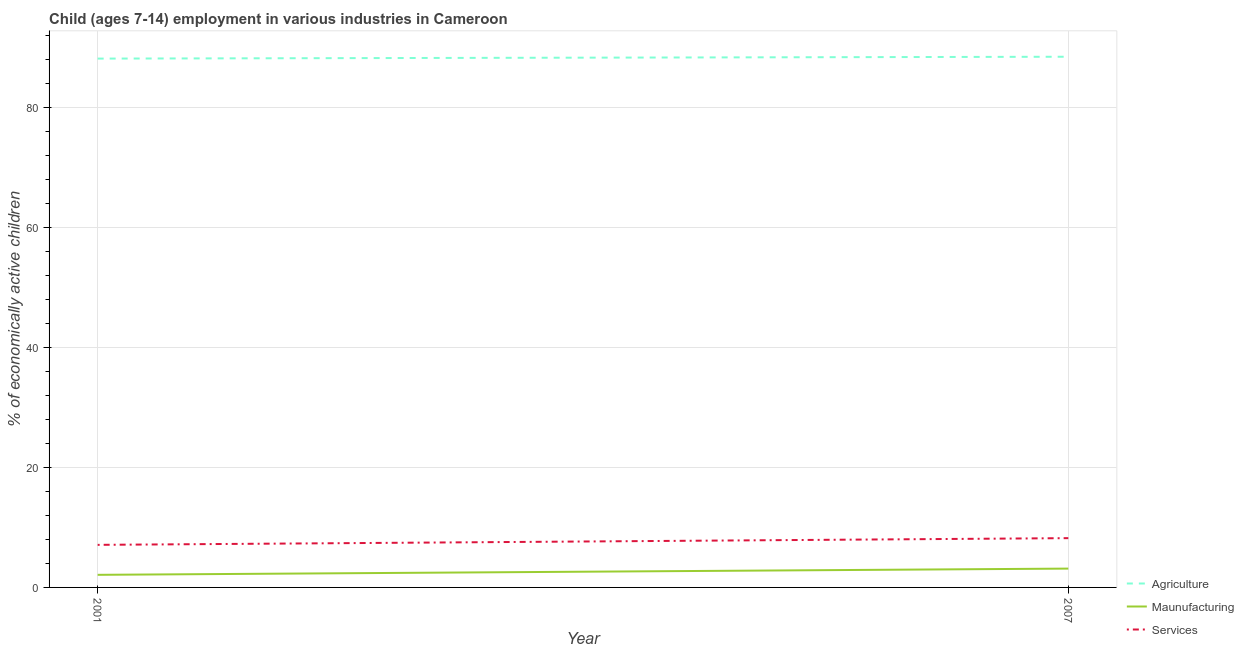Does the line corresponding to percentage of economically active children in services intersect with the line corresponding to percentage of economically active children in manufacturing?
Offer a very short reply. No. What is the percentage of economically active children in agriculture in 2007?
Give a very brief answer. 88.52. Across all years, what is the maximum percentage of economically active children in agriculture?
Keep it short and to the point. 88.52. Across all years, what is the minimum percentage of economically active children in agriculture?
Ensure brevity in your answer.  88.21. In which year was the percentage of economically active children in agriculture maximum?
Ensure brevity in your answer.  2007. What is the total percentage of economically active children in manufacturing in the graph?
Provide a succinct answer. 5.24. What is the difference between the percentage of economically active children in agriculture in 2001 and that in 2007?
Provide a short and direct response. -0.31. What is the difference between the percentage of economically active children in manufacturing in 2007 and the percentage of economically active children in services in 2001?
Provide a succinct answer. -3.96. What is the average percentage of economically active children in services per year?
Keep it short and to the point. 7.66. In the year 2001, what is the difference between the percentage of economically active children in services and percentage of economically active children in agriculture?
Give a very brief answer. -81.11. What is the ratio of the percentage of economically active children in agriculture in 2001 to that in 2007?
Provide a succinct answer. 1. Is the percentage of economically active children in services in 2001 less than that in 2007?
Make the answer very short. Yes. Is it the case that in every year, the sum of the percentage of economically active children in agriculture and percentage of economically active children in manufacturing is greater than the percentage of economically active children in services?
Offer a very short reply. Yes. Does the percentage of economically active children in services monotonically increase over the years?
Provide a short and direct response. Yes. Is the percentage of economically active children in services strictly less than the percentage of economically active children in manufacturing over the years?
Make the answer very short. No. What is the difference between two consecutive major ticks on the Y-axis?
Your answer should be very brief. 20. Does the graph contain grids?
Make the answer very short. Yes. What is the title of the graph?
Provide a succinct answer. Child (ages 7-14) employment in various industries in Cameroon. Does "Argument" appear as one of the legend labels in the graph?
Your answer should be compact. No. What is the label or title of the Y-axis?
Offer a terse response. % of economically active children. What is the % of economically active children in Agriculture in 2001?
Provide a succinct answer. 88.21. What is the % of economically active children of Maunufacturing in 2001?
Give a very brief answer. 2.1. What is the % of economically active children in Services in 2001?
Your response must be concise. 7.1. What is the % of economically active children of Agriculture in 2007?
Give a very brief answer. 88.52. What is the % of economically active children in Maunufacturing in 2007?
Offer a very short reply. 3.14. What is the % of economically active children of Services in 2007?
Keep it short and to the point. 8.22. Across all years, what is the maximum % of economically active children in Agriculture?
Give a very brief answer. 88.52. Across all years, what is the maximum % of economically active children of Maunufacturing?
Your answer should be compact. 3.14. Across all years, what is the maximum % of economically active children in Services?
Your response must be concise. 8.22. Across all years, what is the minimum % of economically active children of Agriculture?
Make the answer very short. 88.21. What is the total % of economically active children of Agriculture in the graph?
Offer a terse response. 176.73. What is the total % of economically active children of Maunufacturing in the graph?
Provide a short and direct response. 5.24. What is the total % of economically active children in Services in the graph?
Your response must be concise. 15.32. What is the difference between the % of economically active children in Agriculture in 2001 and that in 2007?
Provide a short and direct response. -0.31. What is the difference between the % of economically active children of Maunufacturing in 2001 and that in 2007?
Offer a very short reply. -1.04. What is the difference between the % of economically active children in Services in 2001 and that in 2007?
Your answer should be compact. -1.12. What is the difference between the % of economically active children of Agriculture in 2001 and the % of economically active children of Maunufacturing in 2007?
Provide a short and direct response. 85.07. What is the difference between the % of economically active children in Agriculture in 2001 and the % of economically active children in Services in 2007?
Give a very brief answer. 79.99. What is the difference between the % of economically active children in Maunufacturing in 2001 and the % of economically active children in Services in 2007?
Make the answer very short. -6.12. What is the average % of economically active children of Agriculture per year?
Give a very brief answer. 88.36. What is the average % of economically active children of Maunufacturing per year?
Your answer should be very brief. 2.62. What is the average % of economically active children in Services per year?
Ensure brevity in your answer.  7.66. In the year 2001, what is the difference between the % of economically active children in Agriculture and % of economically active children in Maunufacturing?
Your response must be concise. 86.11. In the year 2001, what is the difference between the % of economically active children in Agriculture and % of economically active children in Services?
Offer a very short reply. 81.11. In the year 2007, what is the difference between the % of economically active children in Agriculture and % of economically active children in Maunufacturing?
Keep it short and to the point. 85.38. In the year 2007, what is the difference between the % of economically active children in Agriculture and % of economically active children in Services?
Give a very brief answer. 80.3. In the year 2007, what is the difference between the % of economically active children in Maunufacturing and % of economically active children in Services?
Ensure brevity in your answer.  -5.08. What is the ratio of the % of economically active children in Maunufacturing in 2001 to that in 2007?
Make the answer very short. 0.67. What is the ratio of the % of economically active children of Services in 2001 to that in 2007?
Provide a short and direct response. 0.86. What is the difference between the highest and the second highest % of economically active children of Agriculture?
Keep it short and to the point. 0.31. What is the difference between the highest and the second highest % of economically active children of Services?
Make the answer very short. 1.12. What is the difference between the highest and the lowest % of economically active children of Agriculture?
Give a very brief answer. 0.31. What is the difference between the highest and the lowest % of economically active children of Services?
Make the answer very short. 1.12. 